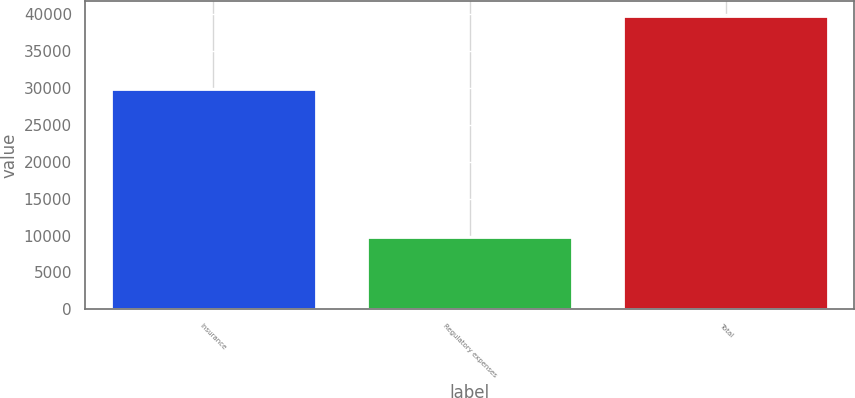<chart> <loc_0><loc_0><loc_500><loc_500><bar_chart><fcel>Insurance<fcel>Regulatory expenses<fcel>Total<nl><fcel>29913<fcel>9865<fcel>39778<nl></chart> 